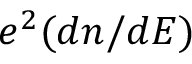<formula> <loc_0><loc_0><loc_500><loc_500>e ^ { 2 } ( d n / d E )</formula> 